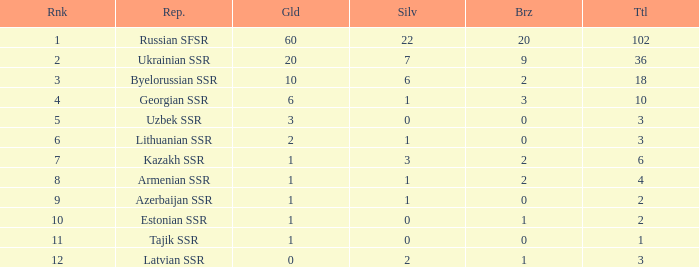What is the total number of bronzes associated with 1 silver, ranks under 6 and under 6 golds? None. 